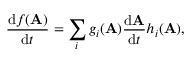<formula> <loc_0><loc_0><loc_500><loc_500>{ \frac { d f ( A ) } { d t } } = \sum _ { i } g _ { i } ( A ) { \frac { d A } { d t } } h _ { i } ( A ) ,</formula> 